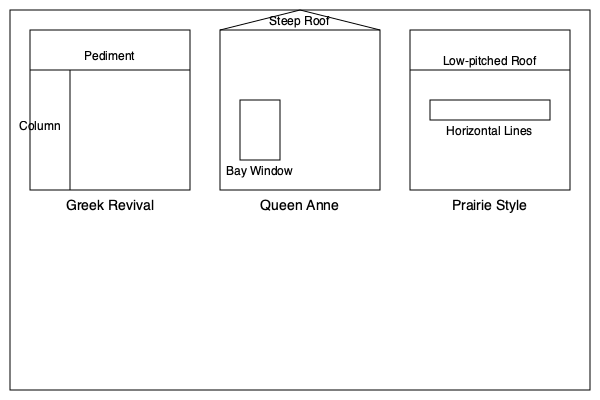Analyze the architectural styles depicted in the diagram and identify which style is most likely to be found in Barrett, Minnesota's historic district. Explain your reasoning based on the town's settlement history and regional influences. To answer this question, we need to consider the historical context of Barrett, Minnesota, and compare it with the characteristics of the architectural styles shown in the diagram:

1. Greek Revival (1825-1860):
   - Features: Pediments, columns, symmetrical shape
   - Historical context: Popular in the early to mid-19th century

2. Queen Anne (1880-1910):
   - Features: Steep roof, bay windows, asymmetrical shape
   - Historical context: Popular in the late 19th century

3. Prairie Style (1900-1920):
   - Features: Low-pitched roof, horizontal lines, emphasis on craftsmanship
   - Historical context: Developed in the Midwest, particularly Chicago, in the early 20th century

Now, let's consider Barrett's history:

1. Barrett was founded in 1887 as a railroad town.
2. The town experienced significant growth in the late 19th and early 20th centuries.
3. As a Midwestern town, it was likely influenced by architectural trends from nearby urban centers.

Given this information:

1. Greek Revival is least likely, as it predates Barrett's founding by several decades.
2. Queen Anne style aligns well with Barrett's founding and early growth period.
3. Prairie Style, while regionally relevant, emerged slightly later than Barrett's initial development.

Considering these factors, the Queen Anne style is most likely to be prevalent in Barrett's historic district. This style was popular during the town's founding and early growth period, and its ornate features would have been favored by successful merchants and residents during the town's prosperous years.
Answer: Queen Anne style 